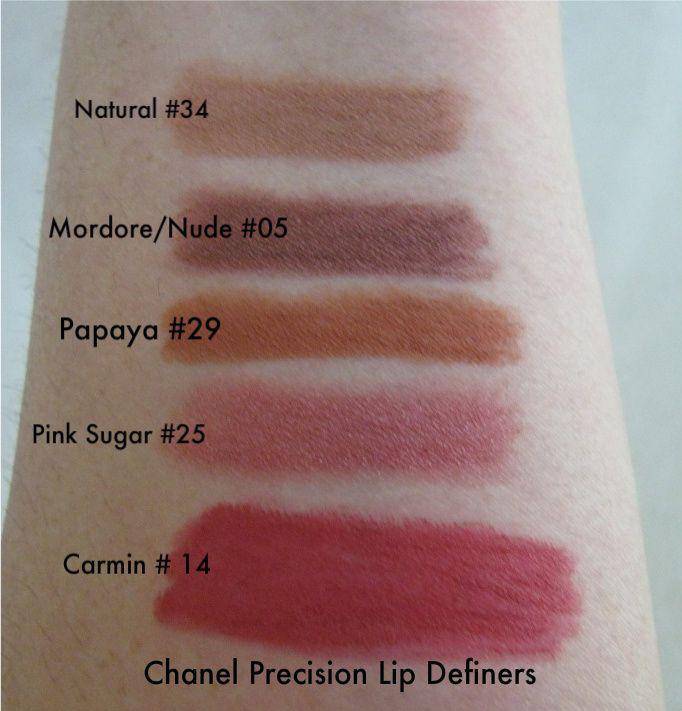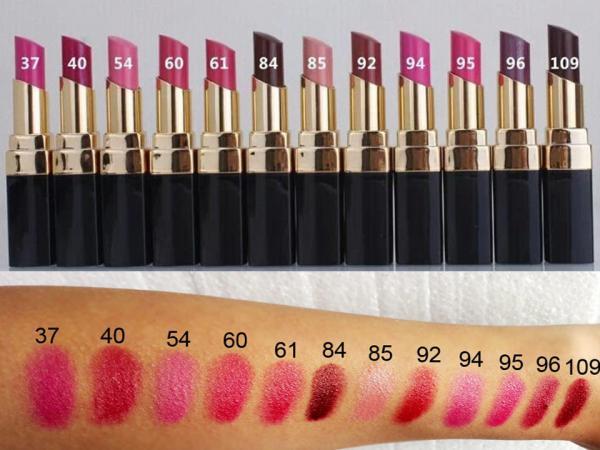The first image is the image on the left, the second image is the image on the right. Assess this claim about the two images: "Each image shows lipstick marks on skin displayed in a horizontal row.". Correct or not? Answer yes or no. No. The first image is the image on the left, the second image is the image on the right. For the images displayed, is the sentence "The person in the left image has lighter skin than the person in the right image." factually correct? Answer yes or no. Yes. 